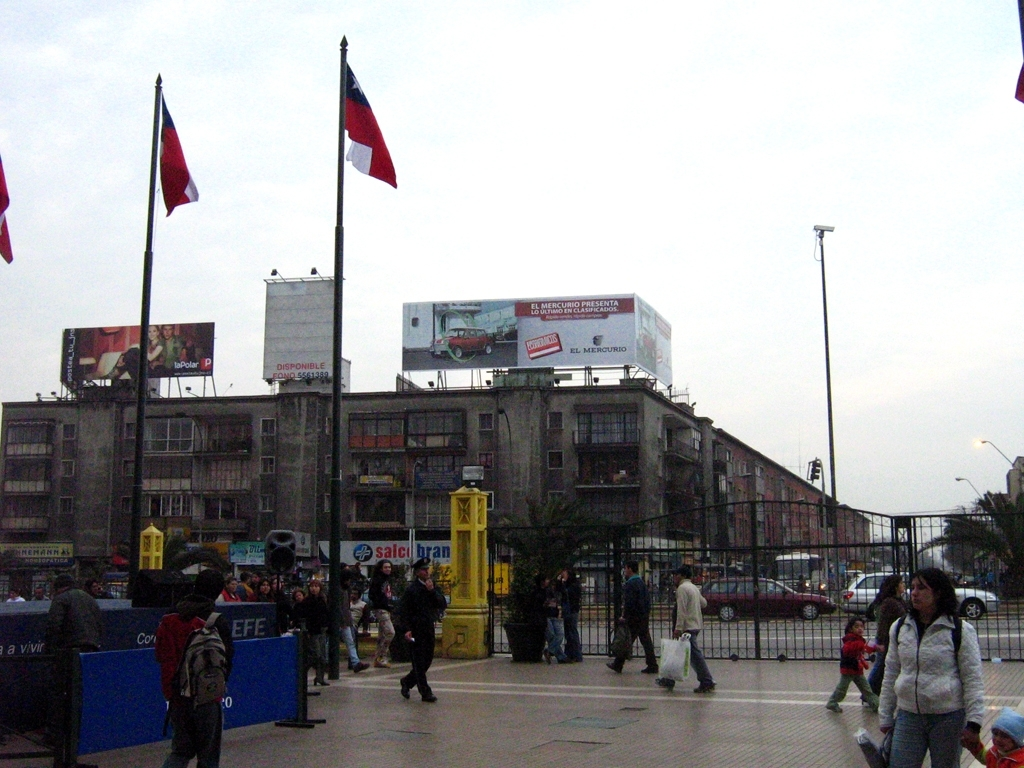Can you tell what activities are happening in this space? This space is bustling with various activities. You can see several pedestrians walking, probably locals going about their everyday tasks. Also, there's a group of people possibly waiting at a bus stop. The presence of flags suggests it might be a significant public area or near a governmental building. What do the flags imply about this location? The flags are national flags, which often indicate a government-related location or a place of national significance. This could be a central area in a city where public transportation is accessible and near important civic buildings or landmarks. 